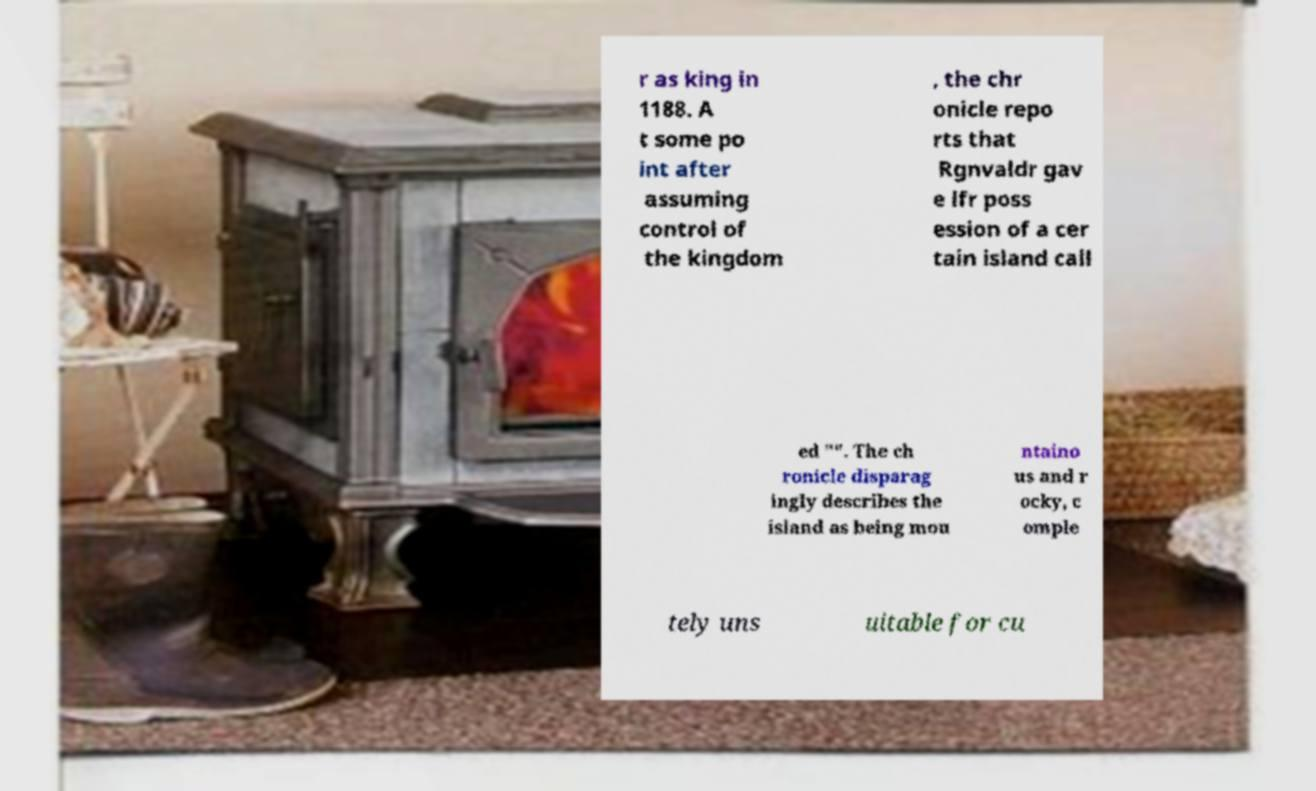Can you accurately transcribe the text from the provided image for me? r as king in 1188. A t some po int after assuming control of the kingdom , the chr onicle repo rts that Rgnvaldr gav e lfr poss ession of a cer tain island call ed "". The ch ronicle disparag ingly describes the island as being mou ntaino us and r ocky, c omple tely uns uitable for cu 